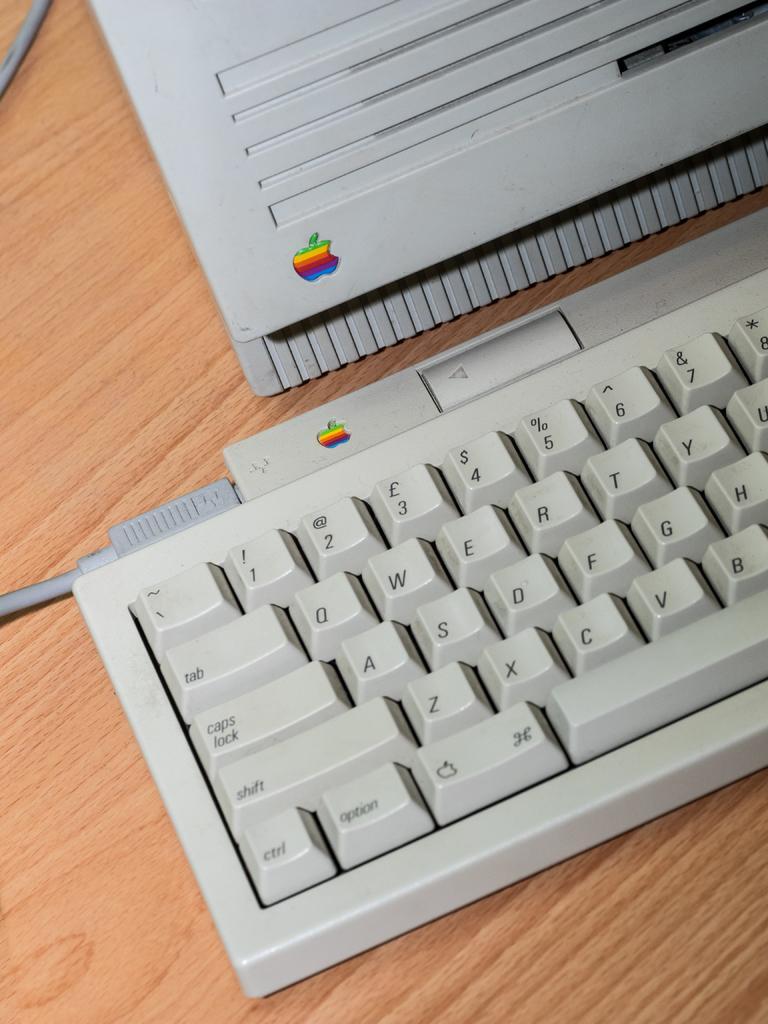In one or two sentences, can you explain what this image depicts? This is a zoomed in picture. In the foreground there is a wooden table on the top of which a laptop, keyboard and a cable is placed. 